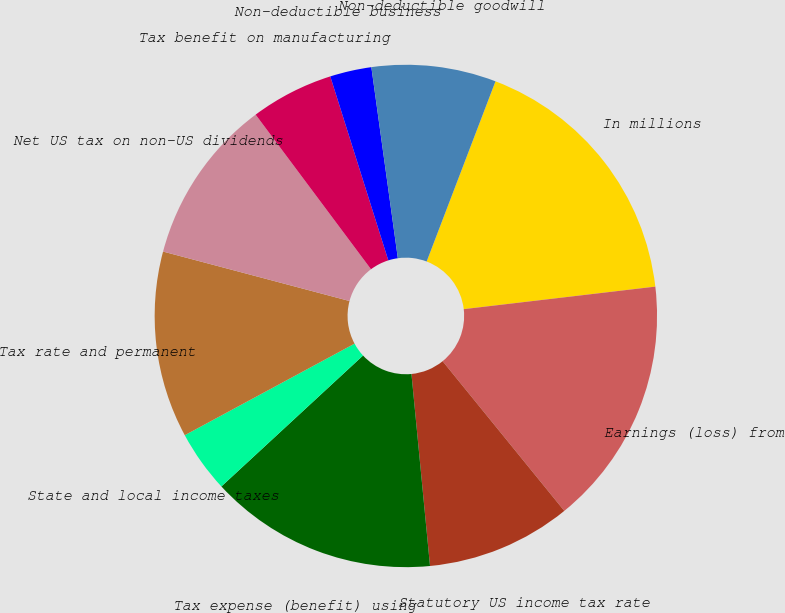<chart> <loc_0><loc_0><loc_500><loc_500><pie_chart><fcel>In millions<fcel>Earnings (loss) from<fcel>Statutory US income tax rate<fcel>Tax expense (benefit) using<fcel>State and local income taxes<fcel>Tax rate and permanent<fcel>Net US tax on non-US dividends<fcel>Tax benefit on manufacturing<fcel>Non-deductible business<fcel>Non-deductible goodwill<nl><fcel>17.33%<fcel>16.0%<fcel>9.33%<fcel>14.66%<fcel>4.0%<fcel>12.0%<fcel>10.67%<fcel>5.34%<fcel>2.67%<fcel>8.0%<nl></chart> 